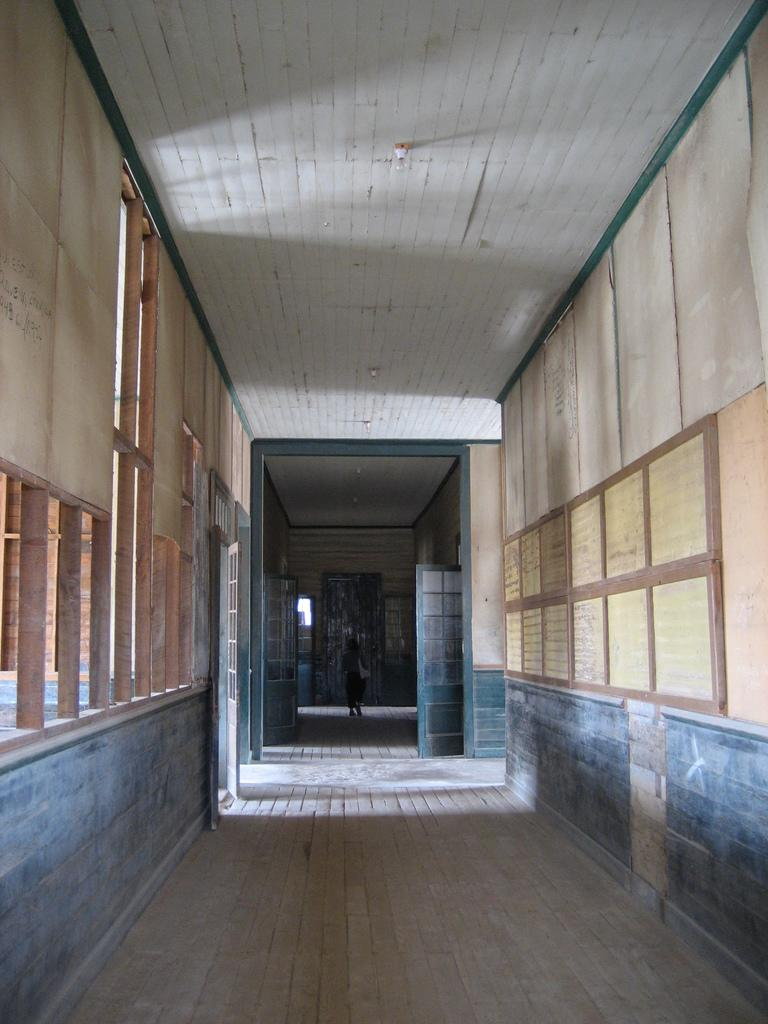What part of a building is shown in the image? The image shows the inner part of a building. What can be seen on the wall in the image? There are boards on the wall. What part of the building's structure is visible in the image? The roof is visible in the image. Can you describe the presence of any people in the image? There is a person in the background of the image. What color is the farm in the image? There is no farm present in the image. 